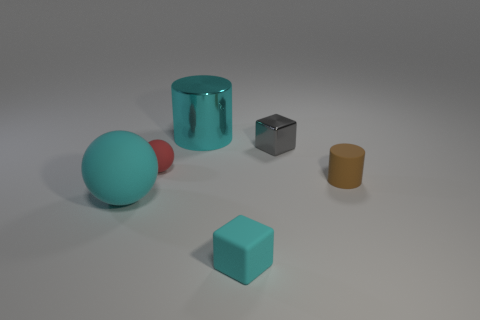Add 3 cyan metallic things. How many objects exist? 9 Subtract all spheres. How many objects are left? 4 Subtract 0 gray cylinders. How many objects are left? 6 Subtract all small gray shiny objects. Subtract all large yellow things. How many objects are left? 5 Add 3 tiny gray objects. How many tiny gray objects are left? 4 Add 3 small purple rubber blocks. How many small purple rubber blocks exist? 3 